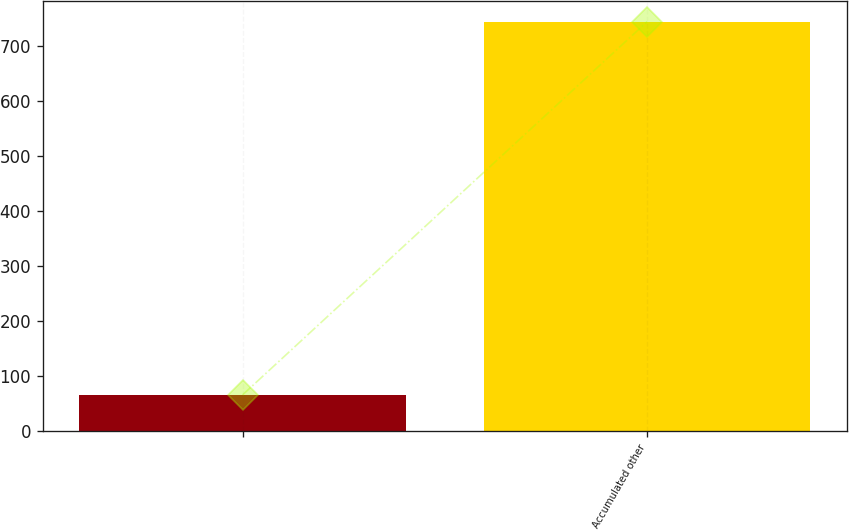Convert chart. <chart><loc_0><loc_0><loc_500><loc_500><bar_chart><ecel><fcel>Accumulated other<nl><fcel>66<fcel>744<nl></chart> 